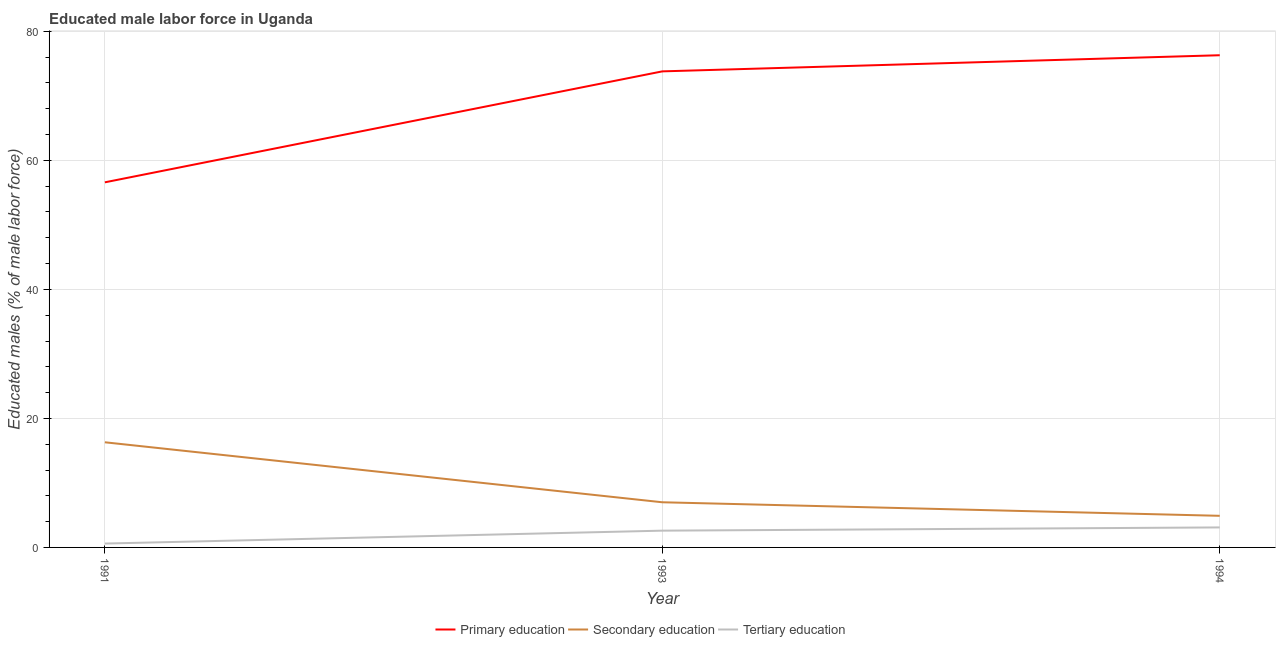How many different coloured lines are there?
Keep it short and to the point. 3. Does the line corresponding to percentage of male labor force who received secondary education intersect with the line corresponding to percentage of male labor force who received primary education?
Ensure brevity in your answer.  No. Is the number of lines equal to the number of legend labels?
Provide a short and direct response. Yes. What is the percentage of male labor force who received primary education in 1991?
Make the answer very short. 56.6. Across all years, what is the maximum percentage of male labor force who received primary education?
Your answer should be very brief. 76.3. Across all years, what is the minimum percentage of male labor force who received tertiary education?
Your answer should be very brief. 0.6. In which year was the percentage of male labor force who received tertiary education minimum?
Keep it short and to the point. 1991. What is the total percentage of male labor force who received secondary education in the graph?
Offer a terse response. 28.2. What is the difference between the percentage of male labor force who received tertiary education in 1991 and that in 1994?
Your response must be concise. -2.5. What is the difference between the percentage of male labor force who received secondary education in 1994 and the percentage of male labor force who received primary education in 1993?
Your answer should be very brief. -68.9. What is the average percentage of male labor force who received primary education per year?
Your response must be concise. 68.9. In the year 1991, what is the difference between the percentage of male labor force who received primary education and percentage of male labor force who received secondary education?
Offer a very short reply. 40.3. In how many years, is the percentage of male labor force who received secondary education greater than 68 %?
Provide a succinct answer. 0. What is the ratio of the percentage of male labor force who received primary education in 1991 to that in 1993?
Make the answer very short. 0.77. Is the percentage of male labor force who received secondary education in 1991 less than that in 1994?
Offer a very short reply. No. What is the difference between the highest and the lowest percentage of male labor force who received tertiary education?
Your response must be concise. 2.5. Is the sum of the percentage of male labor force who received secondary education in 1991 and 1993 greater than the maximum percentage of male labor force who received tertiary education across all years?
Give a very brief answer. Yes. Is it the case that in every year, the sum of the percentage of male labor force who received primary education and percentage of male labor force who received secondary education is greater than the percentage of male labor force who received tertiary education?
Provide a succinct answer. Yes. How many years are there in the graph?
Make the answer very short. 3. Where does the legend appear in the graph?
Provide a short and direct response. Bottom center. How many legend labels are there?
Your answer should be compact. 3. How are the legend labels stacked?
Offer a terse response. Horizontal. What is the title of the graph?
Offer a terse response. Educated male labor force in Uganda. Does "Infant(female)" appear as one of the legend labels in the graph?
Provide a succinct answer. No. What is the label or title of the Y-axis?
Provide a short and direct response. Educated males (% of male labor force). What is the Educated males (% of male labor force) in Primary education in 1991?
Provide a short and direct response. 56.6. What is the Educated males (% of male labor force) of Secondary education in 1991?
Make the answer very short. 16.3. What is the Educated males (% of male labor force) of Tertiary education in 1991?
Your answer should be compact. 0.6. What is the Educated males (% of male labor force) of Primary education in 1993?
Offer a terse response. 73.8. What is the Educated males (% of male labor force) of Secondary education in 1993?
Provide a short and direct response. 7. What is the Educated males (% of male labor force) of Tertiary education in 1993?
Your answer should be compact. 2.6. What is the Educated males (% of male labor force) in Primary education in 1994?
Keep it short and to the point. 76.3. What is the Educated males (% of male labor force) of Secondary education in 1994?
Keep it short and to the point. 4.9. What is the Educated males (% of male labor force) of Tertiary education in 1994?
Provide a succinct answer. 3.1. Across all years, what is the maximum Educated males (% of male labor force) of Primary education?
Ensure brevity in your answer.  76.3. Across all years, what is the maximum Educated males (% of male labor force) of Secondary education?
Ensure brevity in your answer.  16.3. Across all years, what is the maximum Educated males (% of male labor force) in Tertiary education?
Offer a very short reply. 3.1. Across all years, what is the minimum Educated males (% of male labor force) in Primary education?
Ensure brevity in your answer.  56.6. Across all years, what is the minimum Educated males (% of male labor force) in Secondary education?
Provide a succinct answer. 4.9. Across all years, what is the minimum Educated males (% of male labor force) of Tertiary education?
Make the answer very short. 0.6. What is the total Educated males (% of male labor force) in Primary education in the graph?
Your answer should be compact. 206.7. What is the total Educated males (% of male labor force) in Secondary education in the graph?
Your response must be concise. 28.2. What is the difference between the Educated males (% of male labor force) of Primary education in 1991 and that in 1993?
Your answer should be very brief. -17.2. What is the difference between the Educated males (% of male labor force) in Secondary education in 1991 and that in 1993?
Give a very brief answer. 9.3. What is the difference between the Educated males (% of male labor force) of Primary education in 1991 and that in 1994?
Offer a very short reply. -19.7. What is the difference between the Educated males (% of male labor force) of Primary education in 1991 and the Educated males (% of male labor force) of Secondary education in 1993?
Ensure brevity in your answer.  49.6. What is the difference between the Educated males (% of male labor force) in Primary education in 1991 and the Educated males (% of male labor force) in Secondary education in 1994?
Offer a very short reply. 51.7. What is the difference between the Educated males (% of male labor force) of Primary education in 1991 and the Educated males (% of male labor force) of Tertiary education in 1994?
Offer a terse response. 53.5. What is the difference between the Educated males (% of male labor force) of Primary education in 1993 and the Educated males (% of male labor force) of Secondary education in 1994?
Give a very brief answer. 68.9. What is the difference between the Educated males (% of male labor force) of Primary education in 1993 and the Educated males (% of male labor force) of Tertiary education in 1994?
Provide a short and direct response. 70.7. What is the average Educated males (% of male labor force) in Primary education per year?
Make the answer very short. 68.9. What is the average Educated males (% of male labor force) in Secondary education per year?
Provide a short and direct response. 9.4. What is the average Educated males (% of male labor force) in Tertiary education per year?
Provide a short and direct response. 2.1. In the year 1991, what is the difference between the Educated males (% of male labor force) in Primary education and Educated males (% of male labor force) in Secondary education?
Make the answer very short. 40.3. In the year 1991, what is the difference between the Educated males (% of male labor force) in Primary education and Educated males (% of male labor force) in Tertiary education?
Your response must be concise. 56. In the year 1993, what is the difference between the Educated males (% of male labor force) of Primary education and Educated males (% of male labor force) of Secondary education?
Make the answer very short. 66.8. In the year 1993, what is the difference between the Educated males (% of male labor force) in Primary education and Educated males (% of male labor force) in Tertiary education?
Offer a very short reply. 71.2. In the year 1993, what is the difference between the Educated males (% of male labor force) in Secondary education and Educated males (% of male labor force) in Tertiary education?
Give a very brief answer. 4.4. In the year 1994, what is the difference between the Educated males (% of male labor force) of Primary education and Educated males (% of male labor force) of Secondary education?
Your response must be concise. 71.4. In the year 1994, what is the difference between the Educated males (% of male labor force) of Primary education and Educated males (% of male labor force) of Tertiary education?
Offer a very short reply. 73.2. What is the ratio of the Educated males (% of male labor force) of Primary education in 1991 to that in 1993?
Your answer should be very brief. 0.77. What is the ratio of the Educated males (% of male labor force) in Secondary education in 1991 to that in 1993?
Offer a very short reply. 2.33. What is the ratio of the Educated males (% of male labor force) in Tertiary education in 1991 to that in 1993?
Keep it short and to the point. 0.23. What is the ratio of the Educated males (% of male labor force) in Primary education in 1991 to that in 1994?
Your answer should be very brief. 0.74. What is the ratio of the Educated males (% of male labor force) of Secondary education in 1991 to that in 1994?
Your answer should be very brief. 3.33. What is the ratio of the Educated males (% of male labor force) of Tertiary education in 1991 to that in 1994?
Make the answer very short. 0.19. What is the ratio of the Educated males (% of male labor force) of Primary education in 1993 to that in 1994?
Offer a terse response. 0.97. What is the ratio of the Educated males (% of male labor force) of Secondary education in 1993 to that in 1994?
Your response must be concise. 1.43. What is the ratio of the Educated males (% of male labor force) in Tertiary education in 1993 to that in 1994?
Provide a succinct answer. 0.84. What is the difference between the highest and the second highest Educated males (% of male labor force) of Primary education?
Your answer should be compact. 2.5. What is the difference between the highest and the lowest Educated males (% of male labor force) of Primary education?
Provide a succinct answer. 19.7. What is the difference between the highest and the lowest Educated males (% of male labor force) in Tertiary education?
Give a very brief answer. 2.5. 